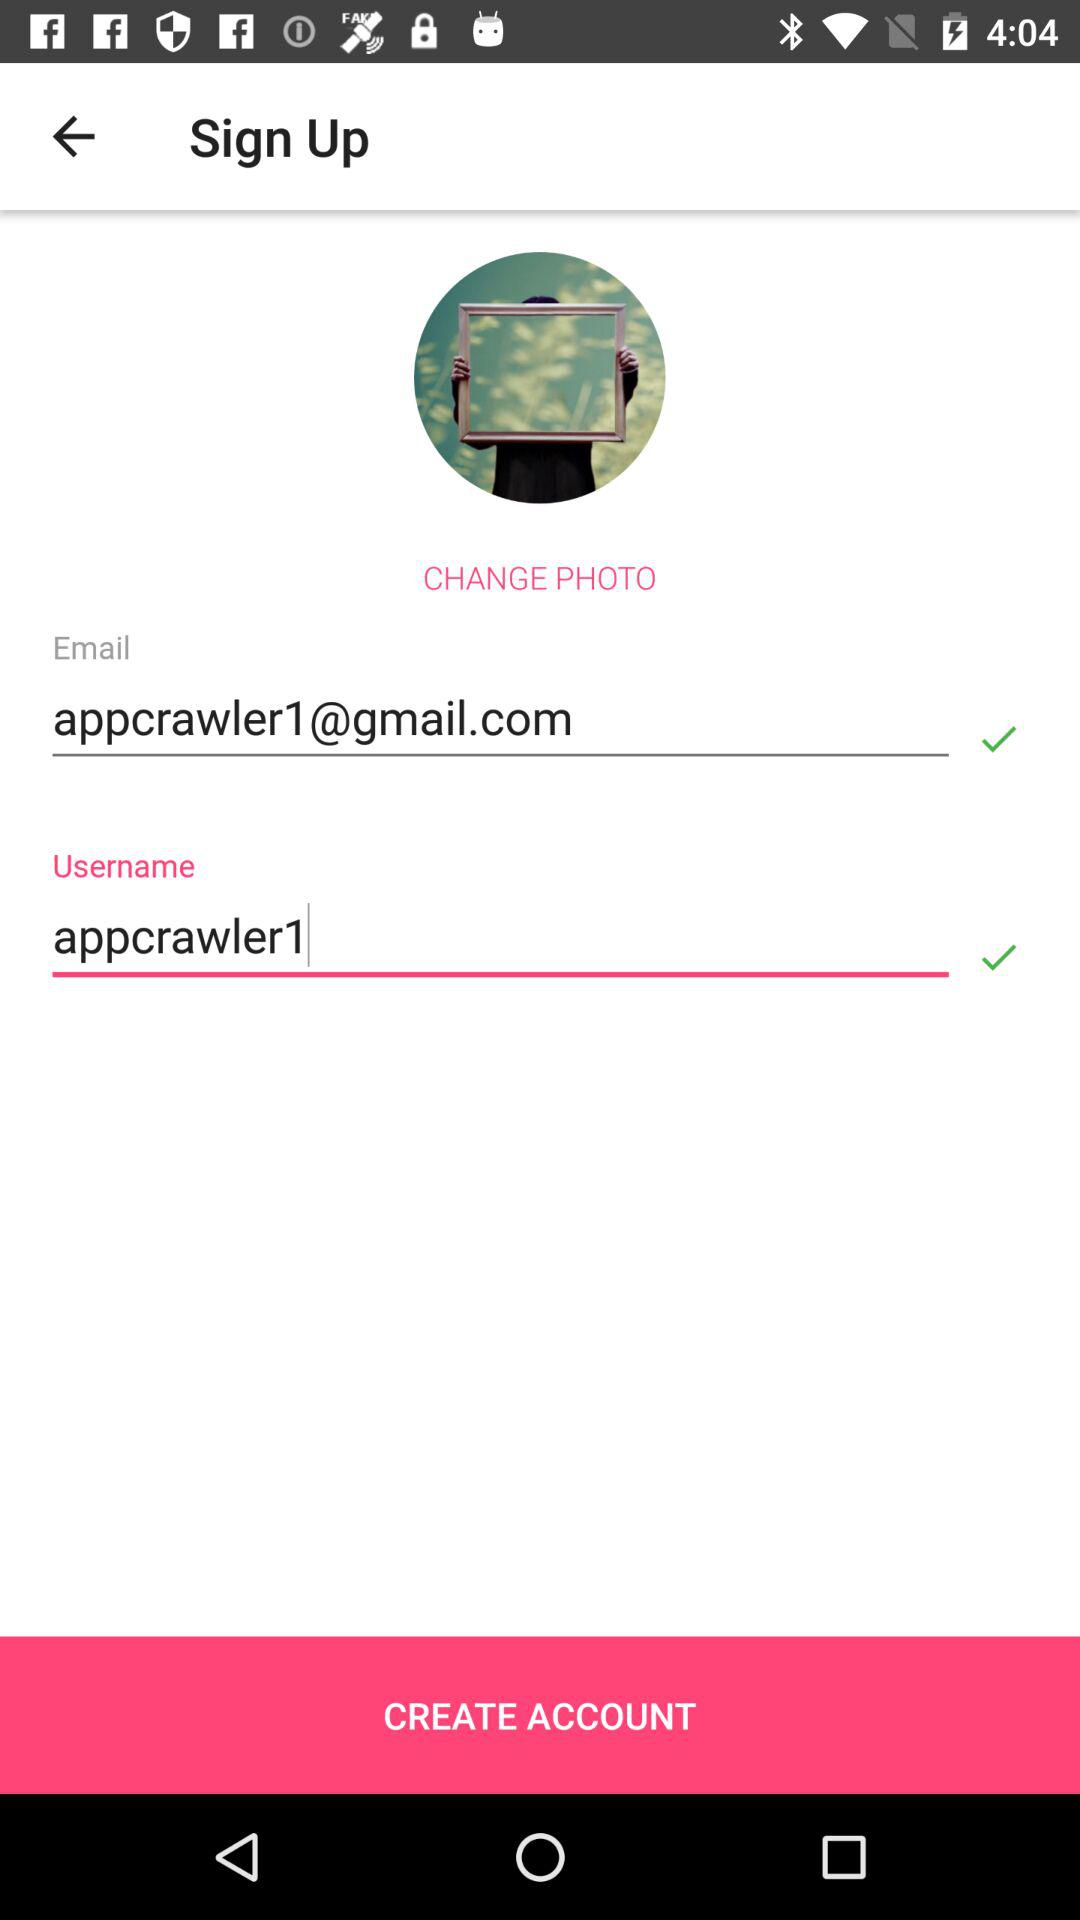What is the email address? The email address is appcrawler1@gmail.com. 